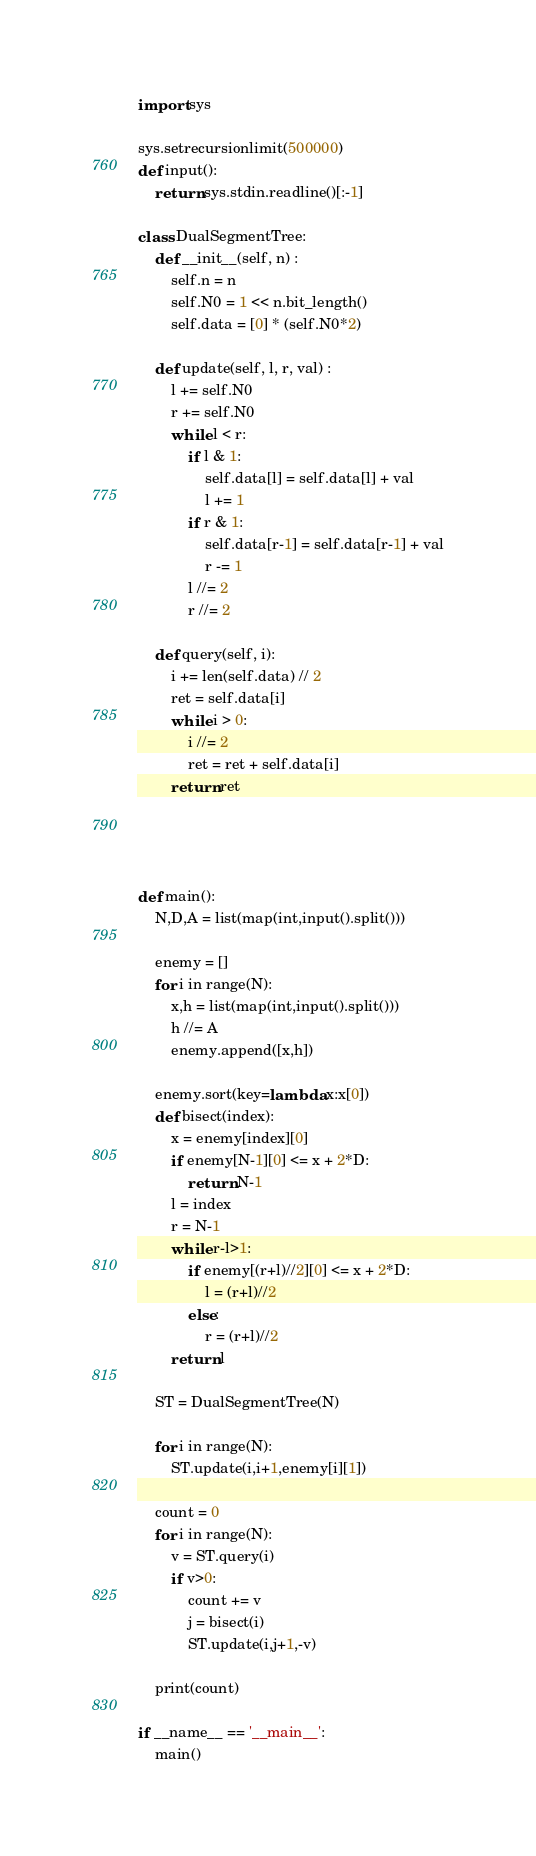<code> <loc_0><loc_0><loc_500><loc_500><_Python_>import sys

sys.setrecursionlimit(500000)
def input():
    return sys.stdin.readline()[:-1]

class DualSegmentTree:
    def __init__(self, n) :
        self.n = n
        self.N0 = 1 << n.bit_length()
        self.data = [0] * (self.N0*2)

    def update(self, l, r, val) :
        l += self.N0
        r += self.N0
        while l < r:
            if l & 1:
                self.data[l] = self.data[l] + val
                l += 1
            if r & 1:
                self.data[r-1] = self.data[r-1] + val
                r -= 1
            l //= 2
            r //= 2

    def query(self, i):
        i += len(self.data) // 2
        ret = self.data[i]
        while i > 0:
            i //= 2
            ret = ret + self.data[i]
        return ret




def main():
    N,D,A = list(map(int,input().split()))

    enemy = []
    for i in range(N):
        x,h = list(map(int,input().split()))
        h //= A
        enemy.append([x,h])

    enemy.sort(key=lambda x:x[0])
    def bisect(index):
        x = enemy[index][0]
        if enemy[N-1][0] <= x + 2*D:
            return N-1
        l = index
        r = N-1
        while r-l>1:
            if enemy[(r+l)//2][0] <= x + 2*D:
                l = (r+l)//2
            else:
                r = (r+l)//2
        return l

    ST = DualSegmentTree(N)

    for i in range(N):
        ST.update(i,i+1,enemy[i][1])

    count = 0
    for i in range(N):
        v = ST.query(i)
        if v>0:
            count += v
            j = bisect(i)
            ST.update(i,j+1,-v) 

    print(count)

if __name__ == '__main__':
    main()

</code> 